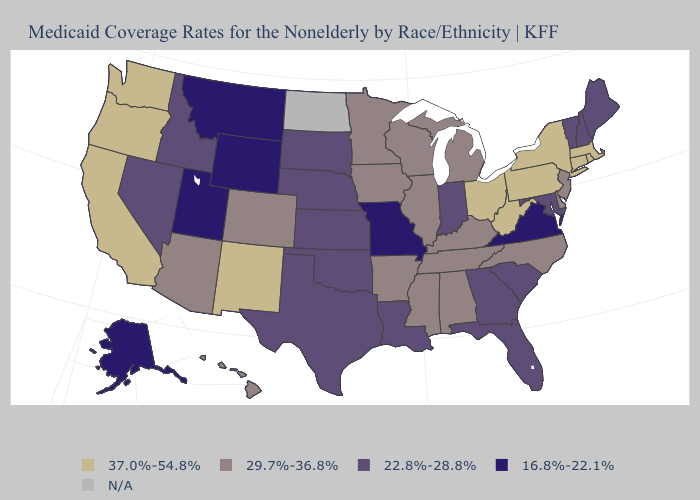What is the value of Maine?
Short answer required. 22.8%-28.8%. Among the states that border Utah , does Colorado have the highest value?
Write a very short answer. No. Among the states that border Alabama , which have the highest value?
Concise answer only. Mississippi, Tennessee. What is the value of Louisiana?
Short answer required. 22.8%-28.8%. Which states have the lowest value in the West?
Write a very short answer. Alaska, Montana, Utah, Wyoming. Which states hav the highest value in the West?
Keep it brief. California, New Mexico, Oregon, Washington. Which states have the highest value in the USA?
Concise answer only. California, Connecticut, Massachusetts, New Mexico, New York, Ohio, Oregon, Pennsylvania, Rhode Island, Washington, West Virginia. Among the states that border South Carolina , which have the lowest value?
Write a very short answer. Georgia. Name the states that have a value in the range 16.8%-22.1%?
Keep it brief. Alaska, Missouri, Montana, Utah, Virginia, Wyoming. What is the lowest value in the Northeast?
Write a very short answer. 22.8%-28.8%. Which states have the highest value in the USA?
Keep it brief. California, Connecticut, Massachusetts, New Mexico, New York, Ohio, Oregon, Pennsylvania, Rhode Island, Washington, West Virginia. Is the legend a continuous bar?
Keep it brief. No. What is the value of North Carolina?
Keep it brief. 29.7%-36.8%. What is the lowest value in states that border Minnesota?
Be succinct. 22.8%-28.8%. 